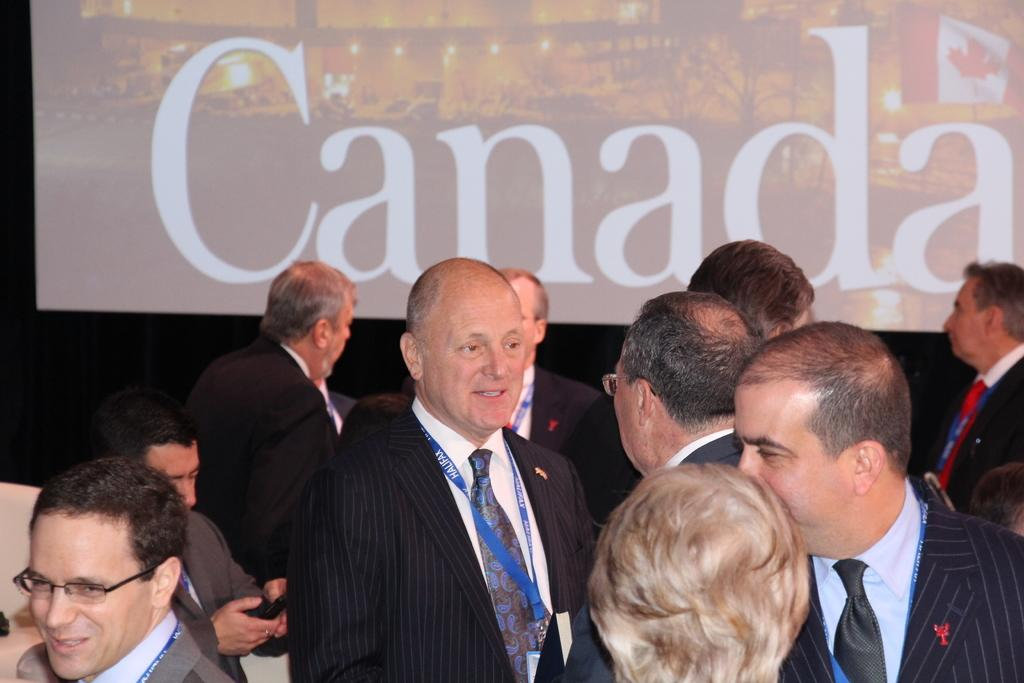What is happening in the image involving the people? The people in the image are engaged in discussion. What can be seen behind the people in the image? There is a background screen present in the image. What type of metal is being used to write on the quill in the image? There is no quill or metal present in the image; it features people engaged in discussion with a background screen. 